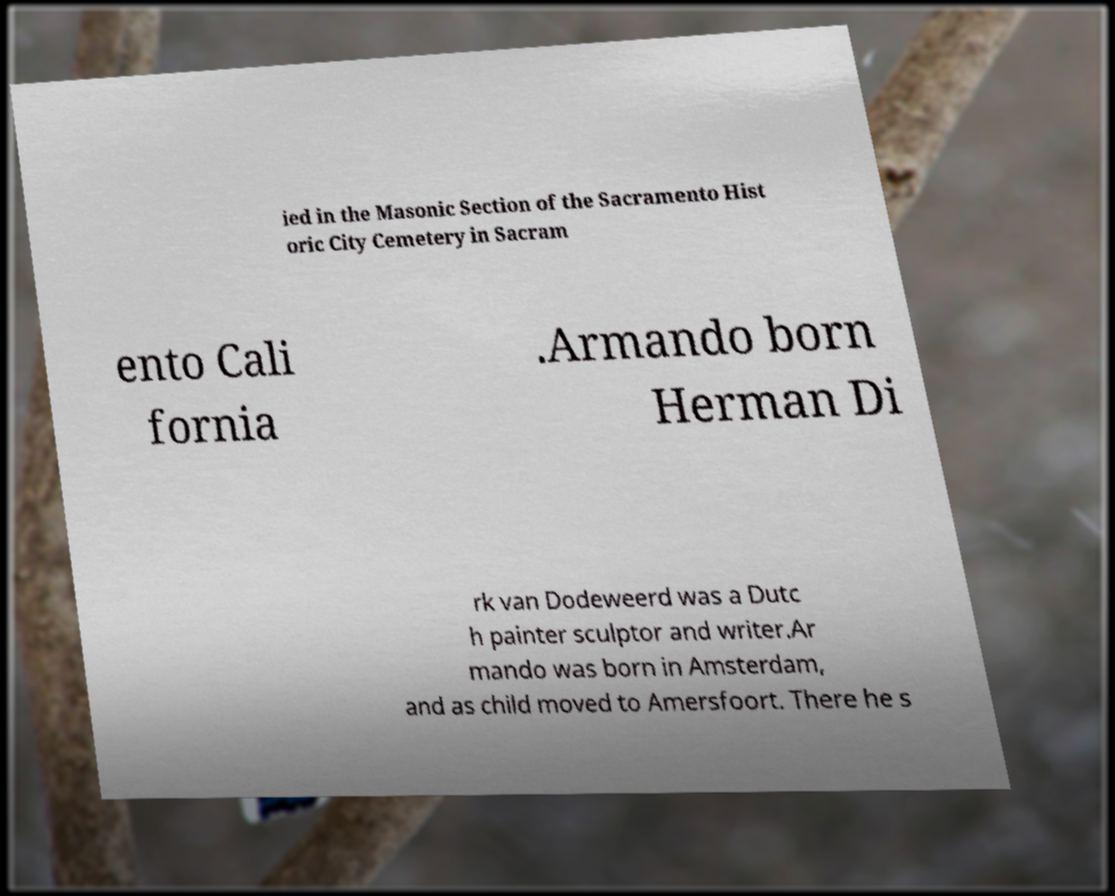There's text embedded in this image that I need extracted. Can you transcribe it verbatim? ied in the Masonic Section of the Sacramento Hist oric City Cemetery in Sacram ento Cali fornia .Armando born Herman Di rk van Dodeweerd was a Dutc h painter sculptor and writer.Ar mando was born in Amsterdam, and as child moved to Amersfoort. There he s 